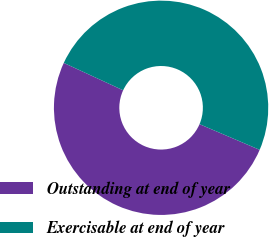Convert chart. <chart><loc_0><loc_0><loc_500><loc_500><pie_chart><fcel>Outstanding at end of year<fcel>Exercisable at end of year<nl><fcel>50.46%<fcel>49.54%<nl></chart> 